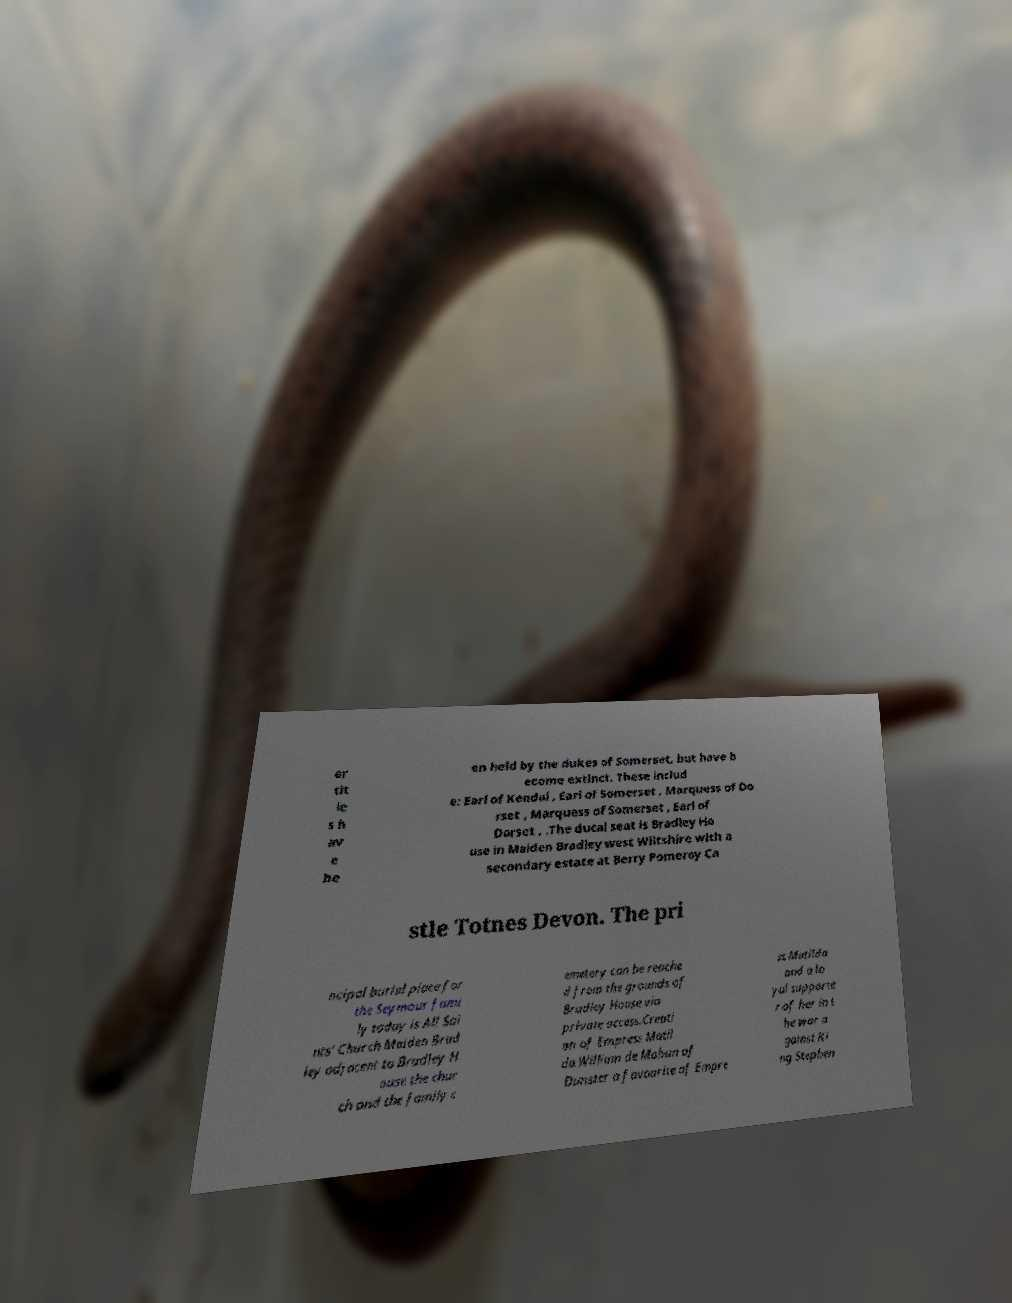Please read and relay the text visible in this image. What does it say? er tit le s h av e be en held by the dukes of Somerset, but have b ecome extinct. These includ e: Earl of Kendal , Earl of Somerset , Marquess of Do rset , Marquess of Somerset , Earl of Dorset , .The ducal seat is Bradley Ho use in Maiden Bradley west Wiltshire with a secondary estate at Berry Pomeroy Ca stle Totnes Devon. The pri ncipal burial place for the Seymour fami ly today is All Sai nts' Church Maiden Brad ley adjacent to Bradley H ouse the chur ch and the family c emetery can be reache d from the grounds of Bradley House via private access.Creati on of Empress Matil da.William de Mohun of Dunster a favourite of Empre ss Matilda and a lo yal supporte r of her in t he war a gainst Ki ng Stephen 